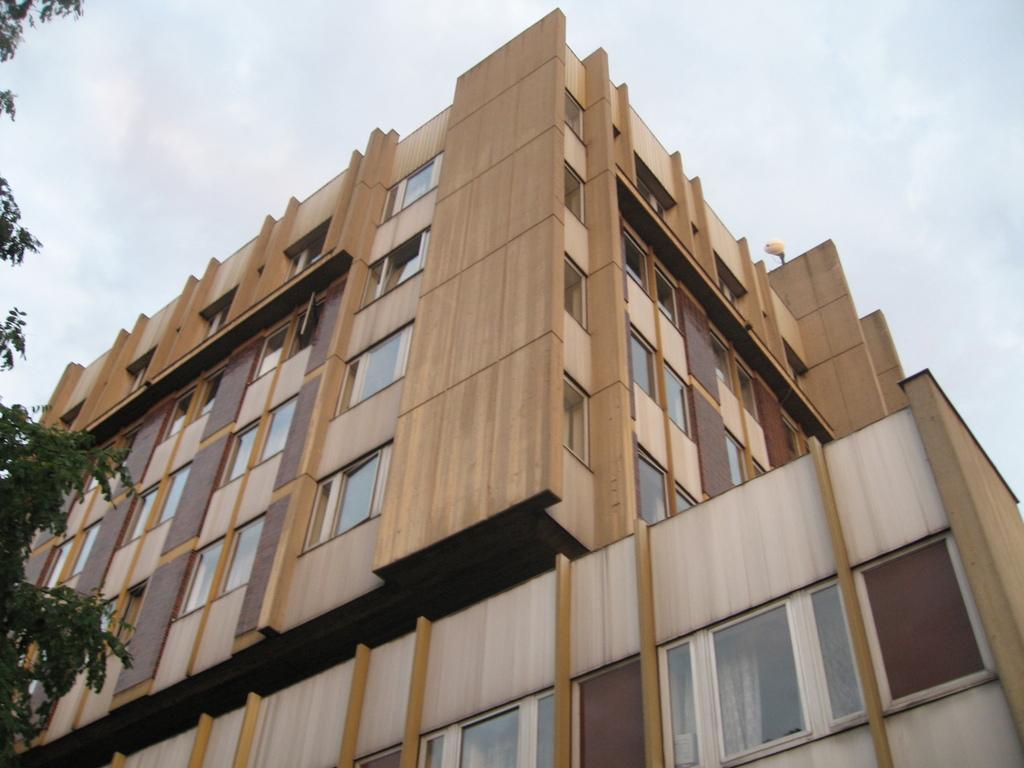Can you describe this image briefly? Here we can see a tree and building. To this building there are windows. Background there is a sky. Sky is cloudy. 